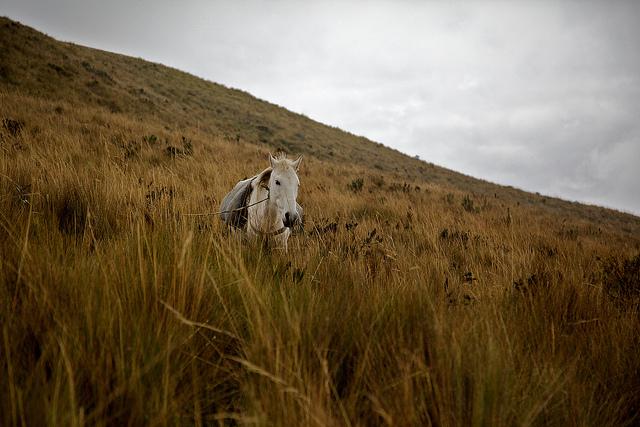What is the landscape of the picture?
Answer briefly. Wilderness. What brand typically uses this animal in its advertisements?
Answer briefly. Marlboro. Is the horse walking through a field?
Give a very brief answer. Yes. Is this picture tilted?
Write a very short answer. No. What color is the horse?
Concise answer only. White. Does this horse look to be wild?
Be succinct. No. Are the animals roaming free range?
Give a very brief answer. Yes. Is the grass green?
Answer briefly. No. Do these horses have on saddles?
Write a very short answer. Yes. Do you see a fence?
Short answer required. No. What color is the animal's face?
Keep it brief. White. 